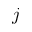Convert formula to latex. <formula><loc_0><loc_0><loc_500><loc_500>j</formula> 